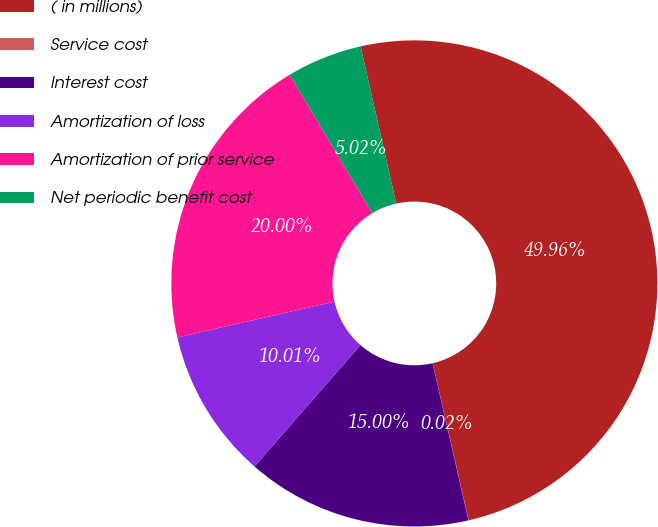Convert chart. <chart><loc_0><loc_0><loc_500><loc_500><pie_chart><fcel>( in millions)<fcel>Service cost<fcel>Interest cost<fcel>Amortization of loss<fcel>Amortization of prior service<fcel>Net periodic benefit cost<nl><fcel>49.96%<fcel>0.02%<fcel>15.0%<fcel>10.01%<fcel>20.0%<fcel>5.02%<nl></chart> 